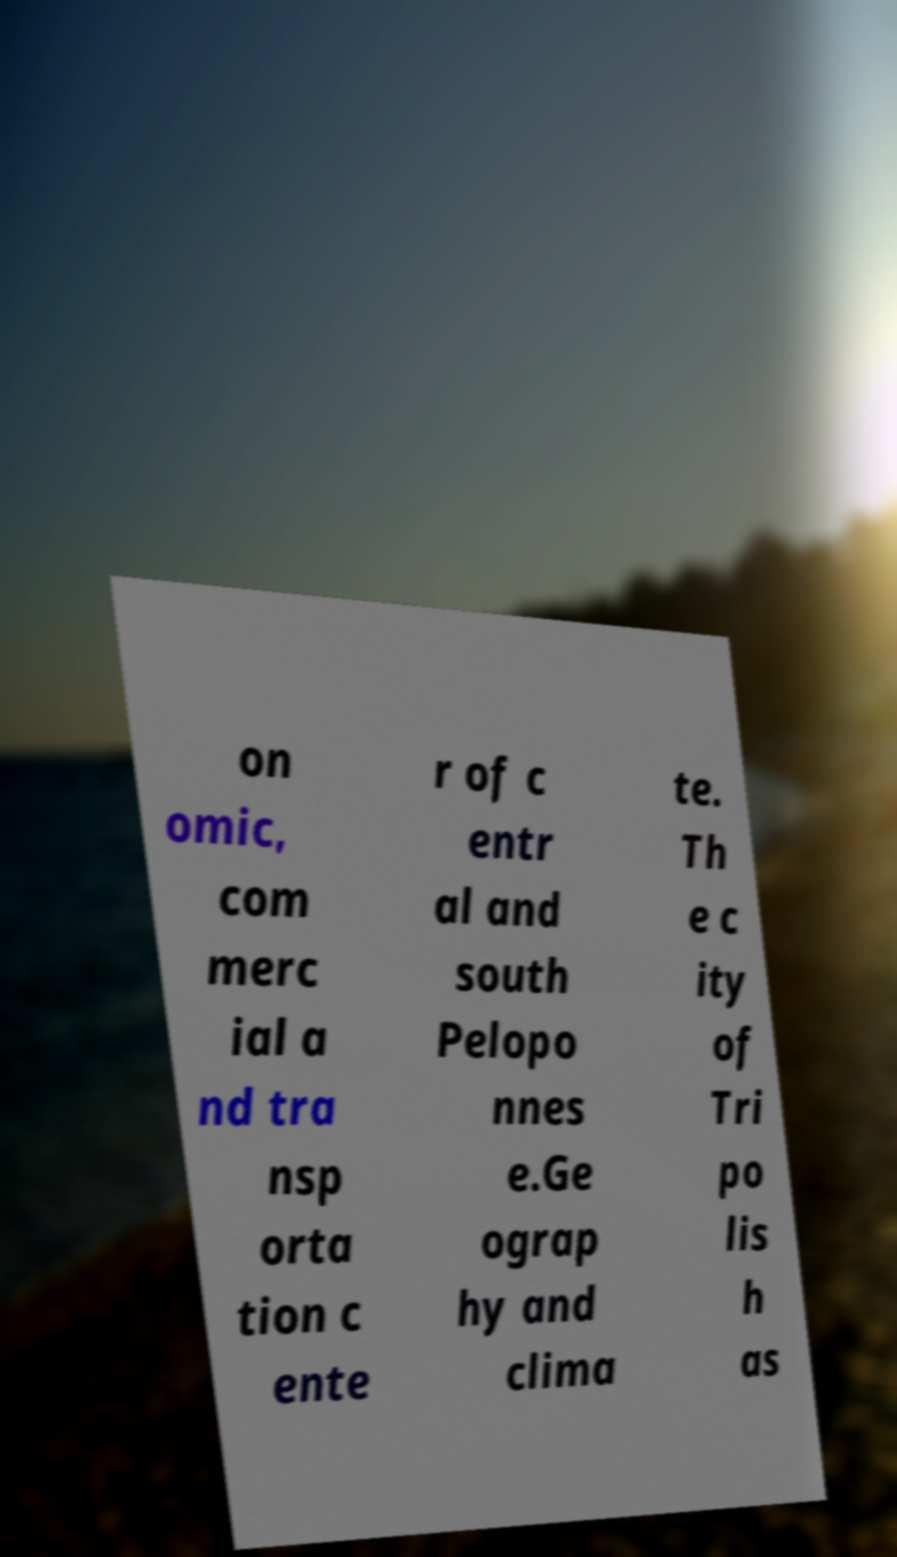Please read and relay the text visible in this image. What does it say? on omic, com merc ial a nd tra nsp orta tion c ente r of c entr al and south Pelopo nnes e.Ge ograp hy and clima te. Th e c ity of Tri po lis h as 